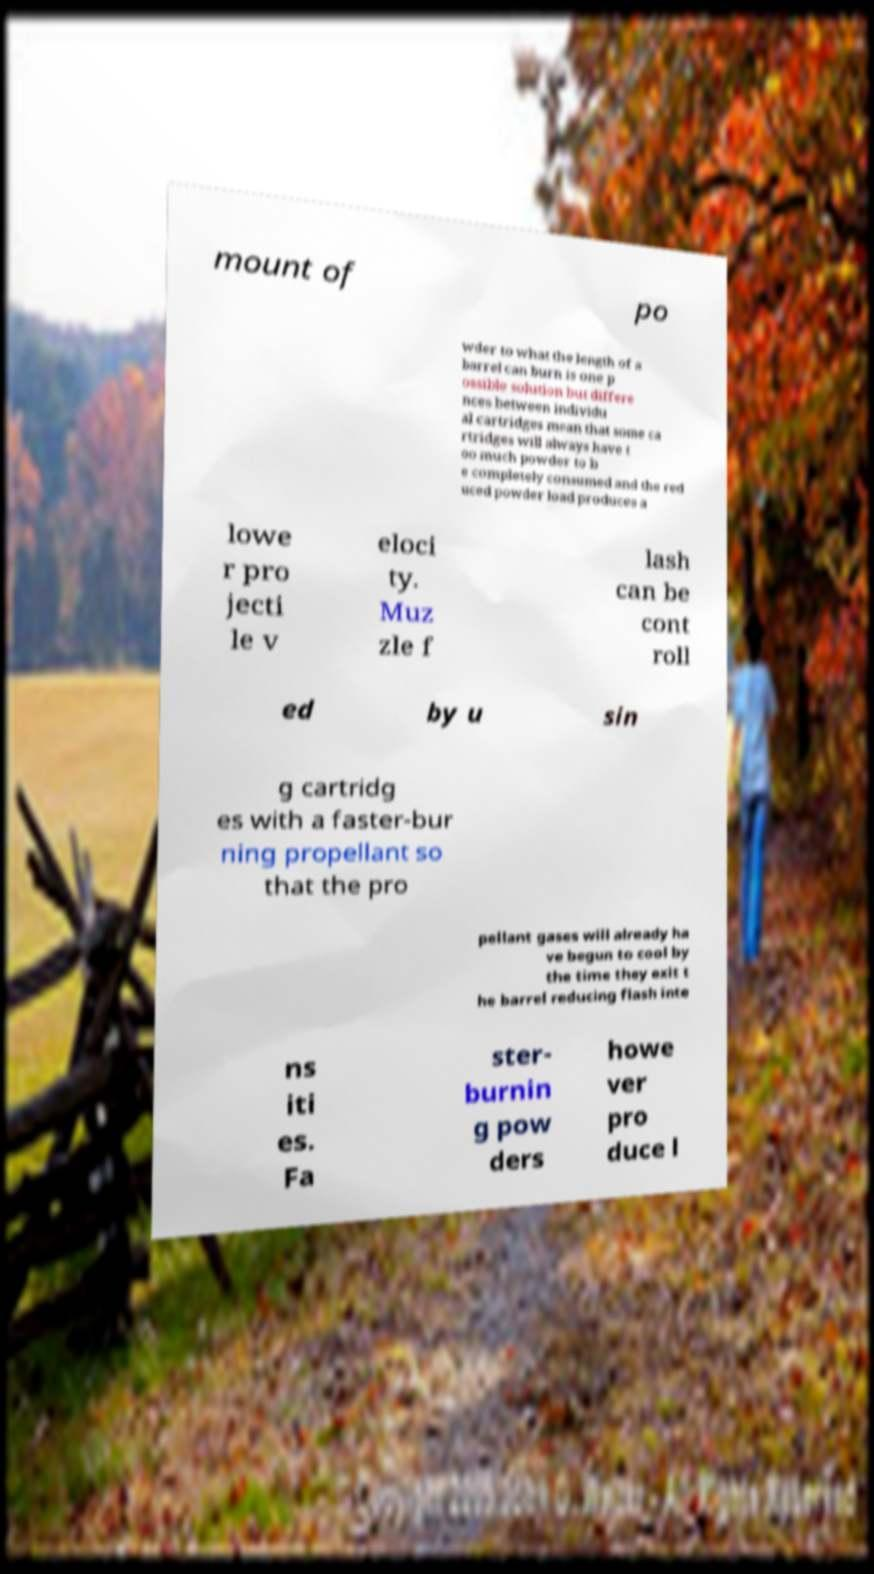Could you assist in decoding the text presented in this image and type it out clearly? mount of po wder to what the length of a barrel can burn is one p ossible solution but differe nces between individu al cartridges mean that some ca rtridges will always have t oo much powder to b e completely consumed and the red uced powder load produces a lowe r pro jecti le v eloci ty. Muz zle f lash can be cont roll ed by u sin g cartridg es with a faster-bur ning propellant so that the pro pellant gases will already ha ve begun to cool by the time they exit t he barrel reducing flash inte ns iti es. Fa ster- burnin g pow ders howe ver pro duce l 